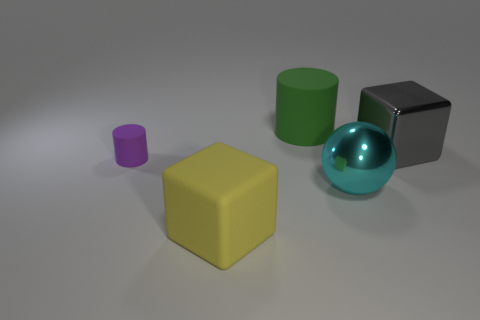Add 5 large brown metallic cylinders. How many objects exist? 10 Subtract all gray blocks. How many blocks are left? 1 Subtract all cylinders. How many objects are left? 3 Add 2 large brown rubber spheres. How many large brown rubber spheres exist? 2 Subtract 0 green spheres. How many objects are left? 5 Subtract all red cubes. Subtract all red balls. How many cubes are left? 2 Subtract all big green matte cylinders. Subtract all tiny objects. How many objects are left? 3 Add 4 large cyan spheres. How many large cyan spheres are left? 5 